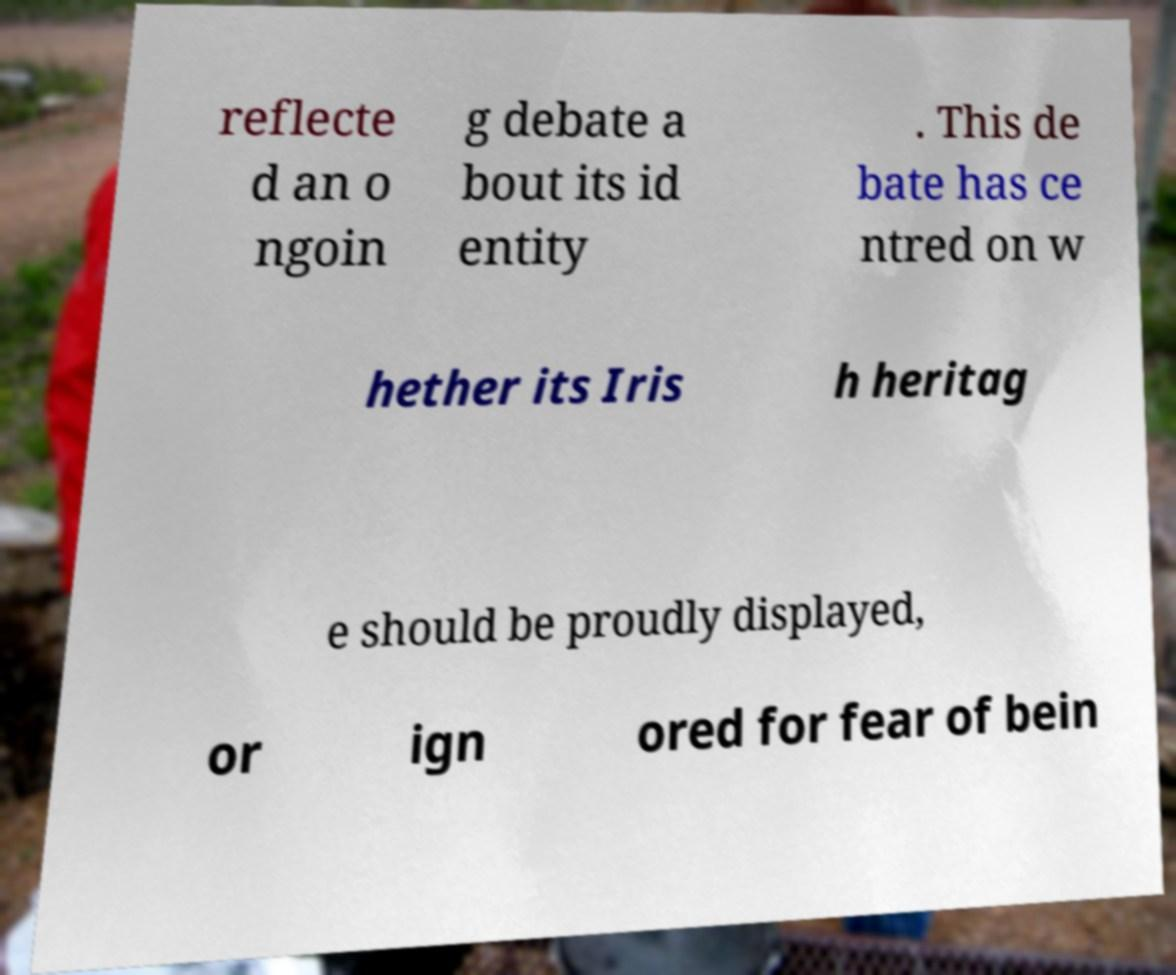Could you assist in decoding the text presented in this image and type it out clearly? reflecte d an o ngoin g debate a bout its id entity . This de bate has ce ntred on w hether its Iris h heritag e should be proudly displayed, or ign ored for fear of bein 